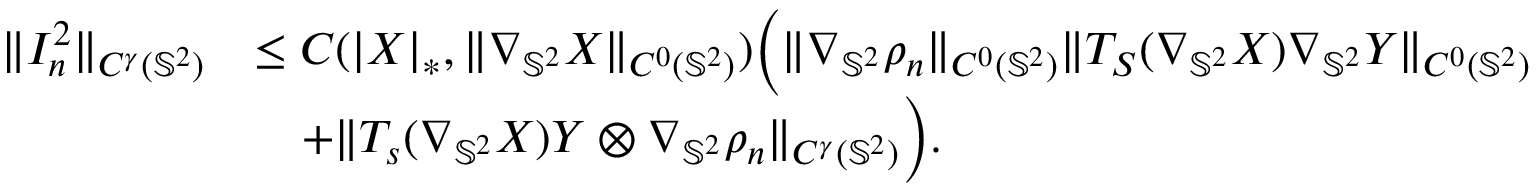Convert formula to latex. <formula><loc_0><loc_0><loc_500><loc_500>\begin{array} { r l } { \| I _ { n } ^ { 2 } \| _ { C ^ { \gamma } ( \mathbb { S } ^ { 2 } ) } } & { \leq C ( | X | _ { * } , \| \nabla _ { \mathbb { S } ^ { 2 } } X \| _ { C ^ { 0 } ( \mathbb { S } ^ { 2 } ) } ) \left ( \| \nabla _ { \mathbb { S } ^ { 2 } } \rho _ { n } \| _ { C ^ { 0 } ( \mathbb { S } ^ { 2 } ) } \| T _ { S } ( \nabla _ { \mathbb { S } ^ { 2 } } X ) \nabla _ { \mathbb { S } ^ { 2 } } Y \| _ { C ^ { 0 } ( \mathbb { S } ^ { 2 } ) } } \\ & { \quad + \| T _ { s } ( \nabla _ { \mathbb { S } ^ { 2 } } X ) Y \otimes \nabla _ { \mathbb { S } ^ { 2 } } \rho _ { n } \| _ { C ^ { \gamma } ( \mathbb { S } ^ { 2 } ) } \right ) . } \end{array}</formula> 